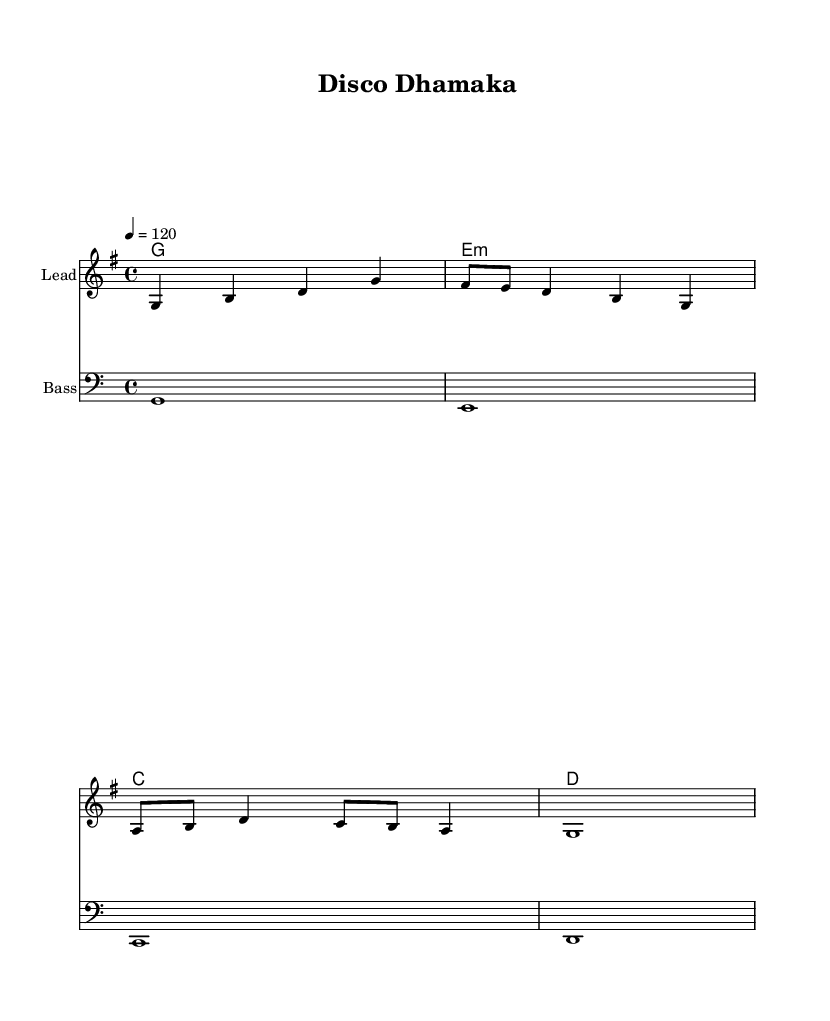What is the key signature of this music? The key signature is G major, which has one sharp (F#). This can be identified by looking at the key signature section at the beginning of the staff.
Answer: G major What is the time signature of this music? The time signature is 4/4, indicated by the fraction at the beginning of the score. This means there are four beats in a measure, and the quarter note receives one beat.
Answer: 4/4 What is the tempo given in this score? The tempo is marked as 120 beats per minute, which is indicated in the score. This informs the performer of the pace at which the music should be played.
Answer: 120 How many measures are in the melody section? The melody section contains four measures, which can be counted by dividing the music into groups defined by the bar lines, each representing a measure.
Answer: 4 What chord is played in the second measure of the harmony? The second measure of the harmony displays an E minor chord, recognizable by the "e:m" notation in the chord names.
Answer: E minor What instrument is indicated for the "Lead" part? The score specifies the "Lead" part without any further notes, but it's implied to be for a solo instrument like a flute or violin based on the context of dance music.
Answer: Lead What type of musical feel does this score represent? The score represents a disco feel, characterized by up-tempo rhythms, syncopated bass lines, and catchy melodies typical of 1970s and 1980s disco music.
Answer: Disco 